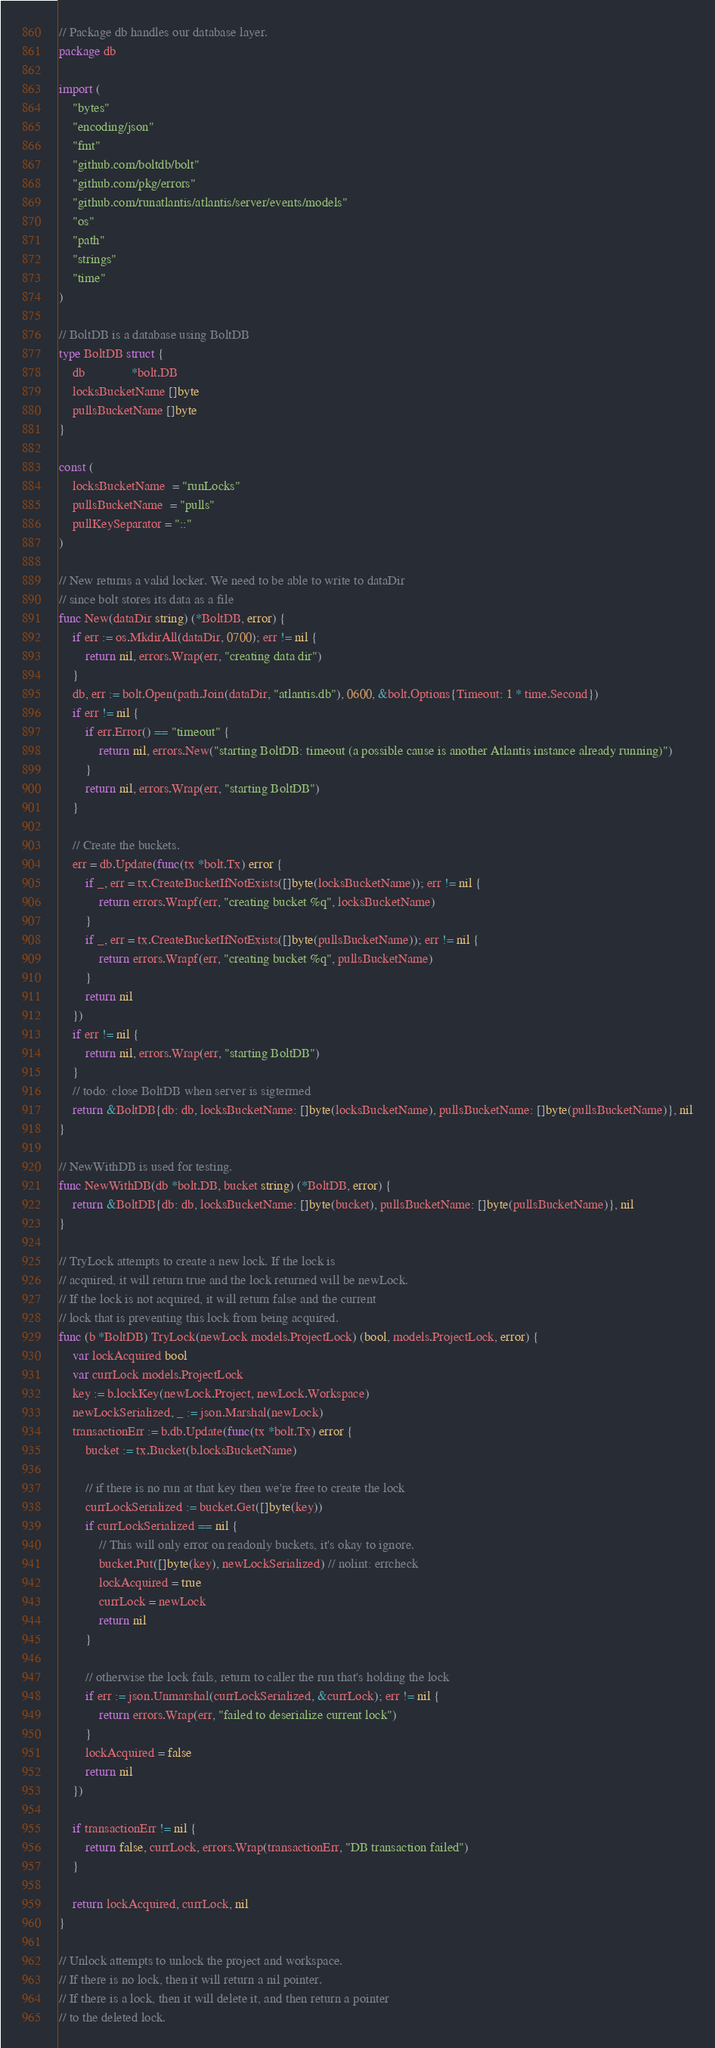Convert code to text. <code><loc_0><loc_0><loc_500><loc_500><_Go_>// Package db handles our database layer.
package db

import (
	"bytes"
	"encoding/json"
	"fmt"
	"github.com/boltdb/bolt"
	"github.com/pkg/errors"
	"github.com/runatlantis/atlantis/server/events/models"
	"os"
	"path"
	"strings"
	"time"
)

// BoltDB is a database using BoltDB
type BoltDB struct {
	db              *bolt.DB
	locksBucketName []byte
	pullsBucketName []byte
}

const (
	locksBucketName  = "runLocks"
	pullsBucketName  = "pulls"
	pullKeySeparator = "::"
)

// New returns a valid locker. We need to be able to write to dataDir
// since bolt stores its data as a file
func New(dataDir string) (*BoltDB, error) {
	if err := os.MkdirAll(dataDir, 0700); err != nil {
		return nil, errors.Wrap(err, "creating data dir")
	}
	db, err := bolt.Open(path.Join(dataDir, "atlantis.db"), 0600, &bolt.Options{Timeout: 1 * time.Second})
	if err != nil {
		if err.Error() == "timeout" {
			return nil, errors.New("starting BoltDB: timeout (a possible cause is another Atlantis instance already running)")
		}
		return nil, errors.Wrap(err, "starting BoltDB")
	}

	// Create the buckets.
	err = db.Update(func(tx *bolt.Tx) error {
		if _, err = tx.CreateBucketIfNotExists([]byte(locksBucketName)); err != nil {
			return errors.Wrapf(err, "creating bucket %q", locksBucketName)
		}
		if _, err = tx.CreateBucketIfNotExists([]byte(pullsBucketName)); err != nil {
			return errors.Wrapf(err, "creating bucket %q", pullsBucketName)
		}
		return nil
	})
	if err != nil {
		return nil, errors.Wrap(err, "starting BoltDB")
	}
	// todo: close BoltDB when server is sigtermed
	return &BoltDB{db: db, locksBucketName: []byte(locksBucketName), pullsBucketName: []byte(pullsBucketName)}, nil
}

// NewWithDB is used for testing.
func NewWithDB(db *bolt.DB, bucket string) (*BoltDB, error) {
	return &BoltDB{db: db, locksBucketName: []byte(bucket), pullsBucketName: []byte(pullsBucketName)}, nil
}

// TryLock attempts to create a new lock. If the lock is
// acquired, it will return true and the lock returned will be newLock.
// If the lock is not acquired, it will return false and the current
// lock that is preventing this lock from being acquired.
func (b *BoltDB) TryLock(newLock models.ProjectLock) (bool, models.ProjectLock, error) {
	var lockAcquired bool
	var currLock models.ProjectLock
	key := b.lockKey(newLock.Project, newLock.Workspace)
	newLockSerialized, _ := json.Marshal(newLock)
	transactionErr := b.db.Update(func(tx *bolt.Tx) error {
		bucket := tx.Bucket(b.locksBucketName)

		// if there is no run at that key then we're free to create the lock
		currLockSerialized := bucket.Get([]byte(key))
		if currLockSerialized == nil {
			// This will only error on readonly buckets, it's okay to ignore.
			bucket.Put([]byte(key), newLockSerialized) // nolint: errcheck
			lockAcquired = true
			currLock = newLock
			return nil
		}

		// otherwise the lock fails, return to caller the run that's holding the lock
		if err := json.Unmarshal(currLockSerialized, &currLock); err != nil {
			return errors.Wrap(err, "failed to deserialize current lock")
		}
		lockAcquired = false
		return nil
	})

	if transactionErr != nil {
		return false, currLock, errors.Wrap(transactionErr, "DB transaction failed")
	}

	return lockAcquired, currLock, nil
}

// Unlock attempts to unlock the project and workspace.
// If there is no lock, then it will return a nil pointer.
// If there is a lock, then it will delete it, and then return a pointer
// to the deleted lock.</code> 